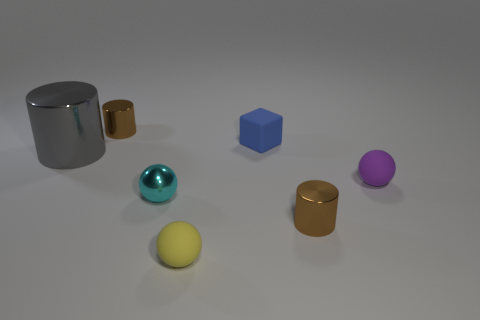Is there a pattern to the colors of the objects? The objects' colors do not appear to be arranged in any specific pattern. There is a variety of colors such as gold, purple, teal, and blue, all somewhat evenly distributed with no repeating sequence or gradient arrangement. 